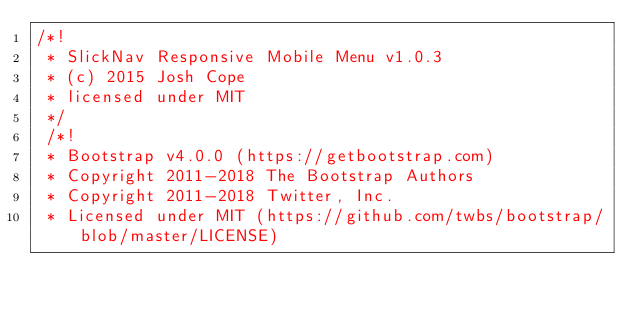Convert code to text. <code><loc_0><loc_0><loc_500><loc_500><_CSS_>/*!
 * SlickNav Responsive Mobile Menu v1.0.3
 * (c) 2015 Josh Cope
 * licensed under MIT
 */
 /*!
 * Bootstrap v4.0.0 (https://getbootstrap.com)
 * Copyright 2011-2018 The Bootstrap Authors
 * Copyright 2011-2018 Twitter, Inc.
 * Licensed under MIT (https://github.com/twbs/bootstrap/blob/master/LICENSE)</code> 